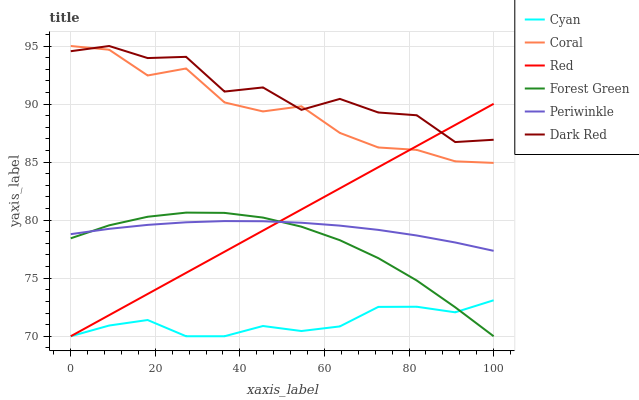Does Cyan have the minimum area under the curve?
Answer yes or no. Yes. Does Dark Red have the maximum area under the curve?
Answer yes or no. Yes. Does Coral have the minimum area under the curve?
Answer yes or no. No. Does Coral have the maximum area under the curve?
Answer yes or no. No. Is Red the smoothest?
Answer yes or no. Yes. Is Dark Red the roughest?
Answer yes or no. Yes. Is Coral the smoothest?
Answer yes or no. No. Is Coral the roughest?
Answer yes or no. No. Does Forest Green have the lowest value?
Answer yes or no. Yes. Does Coral have the lowest value?
Answer yes or no. No. Does Coral have the highest value?
Answer yes or no. Yes. Does Forest Green have the highest value?
Answer yes or no. No. Is Cyan less than Periwinkle?
Answer yes or no. Yes. Is Dark Red greater than Forest Green?
Answer yes or no. Yes. Does Red intersect Forest Green?
Answer yes or no. Yes. Is Red less than Forest Green?
Answer yes or no. No. Is Red greater than Forest Green?
Answer yes or no. No. Does Cyan intersect Periwinkle?
Answer yes or no. No. 